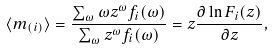<formula> <loc_0><loc_0><loc_500><loc_500>\langle m _ { ( i ) } \rangle = \frac { \sum _ { \omega } \omega z ^ { \omega } f _ { i } ( \omega ) } { \sum _ { \omega } z ^ { \omega } f _ { i } ( \omega ) } = z \frac { \partial \ln F _ { i } ( z ) } { \partial z } ,</formula> 